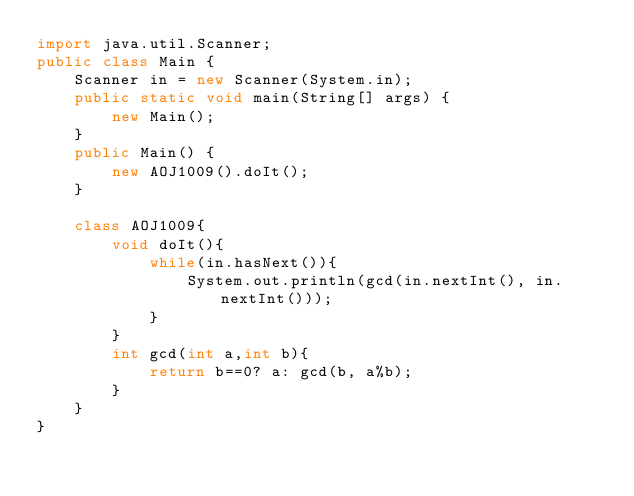Convert code to text. <code><loc_0><loc_0><loc_500><loc_500><_Java_>import java.util.Scanner;
public class Main {
	Scanner in = new Scanner(System.in);
	public static void main(String[] args) {
		new Main();
	}
	public Main() {
		new AOJ1009().doIt();
	}

	class AOJ1009{
		void doIt(){
			while(in.hasNext()){
				System.out.println(gcd(in.nextInt(), in.nextInt()));
			}
		}
		int gcd(int a,int b){
			return b==0? a: gcd(b, a%b);
		}
	}
}</code> 